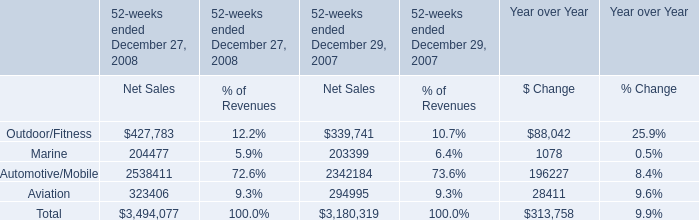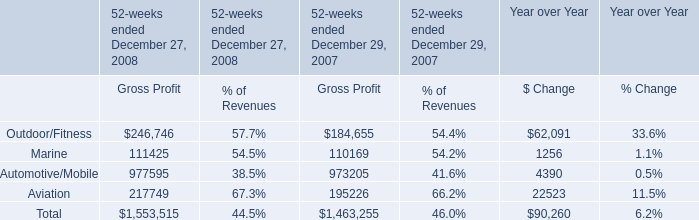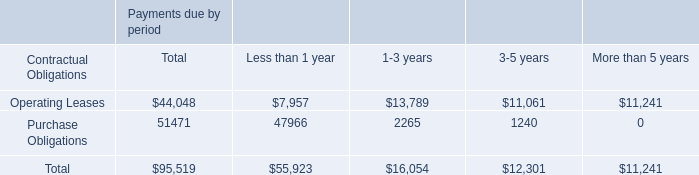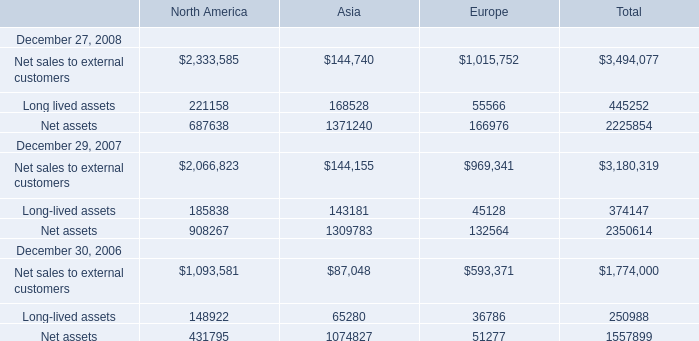What is the ratio of Net assets of Europe in Table 3 to the Aviation of Gross Profit in Table 1 in 2008? 
Computations: (166976 / 217749)
Answer: 0.76683. 